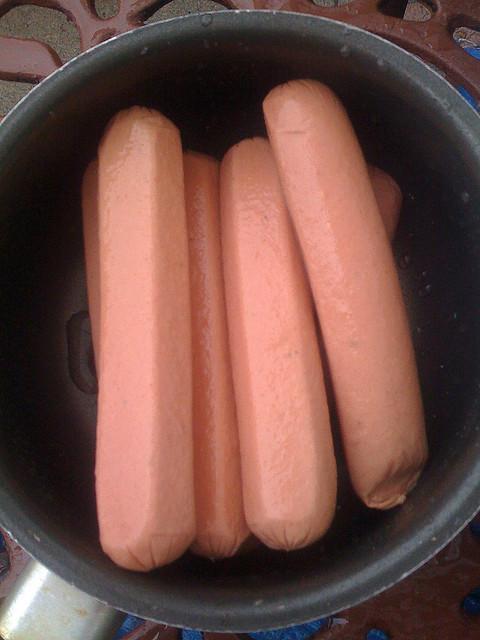Can this ingredient be used to make cake?
Concise answer only. No. Do the hot dogs have grill marks?
Quick response, please. No. What is the hot dog sitting on?
Quick response, please. Pot. What color is the bowl?
Concise answer only. Black. What are the hotdogs in?
Concise answer only. Pot. Is this hot dog enough for two people?
Give a very brief answer. Yes. Is this a bowl or a pot?
Write a very short answer. Pot. What is sticking out of the hot dog?
Be succinct. Nothing. How many hot dogs?
Be succinct. 6. What is in the frying pan?
Write a very short answer. Hot dogs. Is that a sliced hotdog?
Be succinct. No. 